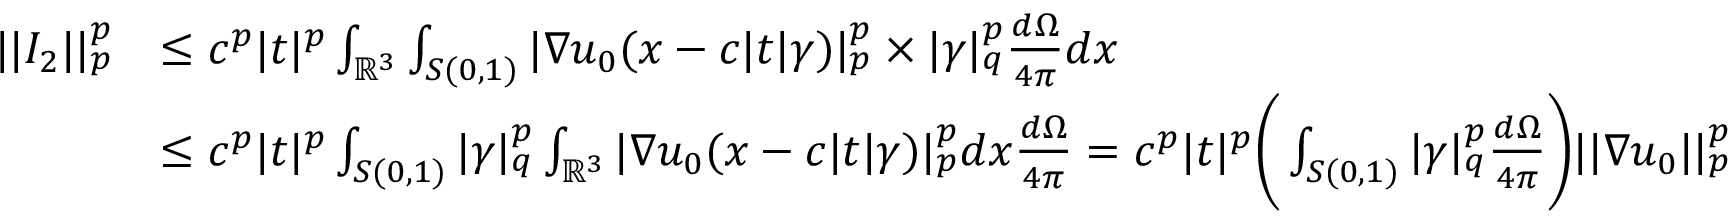<formula> <loc_0><loc_0><loc_500><loc_500>\begin{array} { r l } { | | I _ { 2 } | | _ { p } ^ { p } } & { \leq c ^ { p } | t | ^ { p } \int _ { \mathbb { R } ^ { 3 } } \int _ { S ( 0 , 1 ) } | \nabla u _ { 0 } ( x - c | t | \gamma ) | _ { p } ^ { p } \times | \gamma | _ { q } ^ { p } \frac { d \Omega } { 4 \pi } d x } \\ & { \leq c ^ { p } | t | ^ { p } \int _ { S ( 0 , 1 ) } | \gamma | _ { q } ^ { p } \int _ { \mathbb { R } ^ { 3 } } | \nabla u _ { 0 } ( x - c | t | \gamma ) | _ { p } ^ { p } d x \frac { d \Omega } { 4 \pi } = c ^ { p } | t | ^ { p } \left ( \int _ { S ( 0 , 1 ) } | \gamma | _ { q } ^ { p } \frac { d \Omega } { 4 \pi } \right ) | | \nabla u _ { 0 } | | _ { p } ^ { p } } \end{array}</formula> 